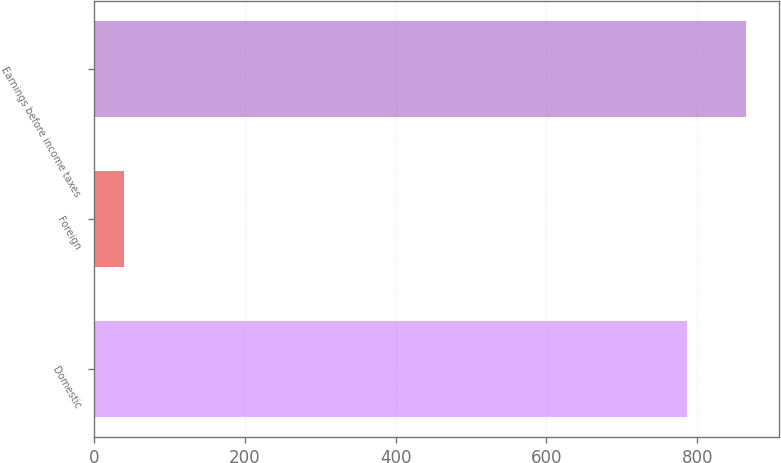Convert chart. <chart><loc_0><loc_0><loc_500><loc_500><bar_chart><fcel>Domestic<fcel>Foreign<fcel>Earnings before income taxes<nl><fcel>786<fcel>40.1<fcel>864.6<nl></chart> 